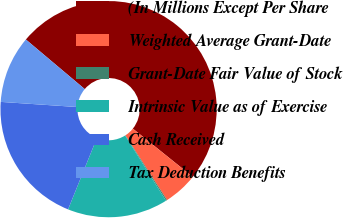<chart> <loc_0><loc_0><loc_500><loc_500><pie_chart><fcel>(In Millions Except Per Share<fcel>Weighted Average Grant-Date<fcel>Grant-Date Fair Value of Stock<fcel>Intrinsic Value as of Exercise<fcel>Cash Received<fcel>Tax Deduction Benefits<nl><fcel>49.64%<fcel>5.13%<fcel>0.18%<fcel>15.02%<fcel>19.96%<fcel>10.07%<nl></chart> 